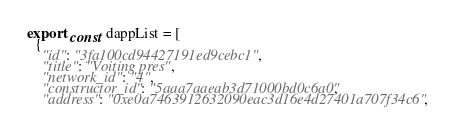Convert code to text. <code><loc_0><loc_0><loc_500><loc_500><_TypeScript_>export const dappList = [
  {
    "id": "3fa100cd94427191ed9cebc1",
    "title": "Voiting pres",
    "network_id": "4",
    "constructor_id": "5aaa7aaeab3d71000bd0c6a0",
    "address": "0xe0a7463912632090eac3d16e4d27401a707f34c6",</code> 